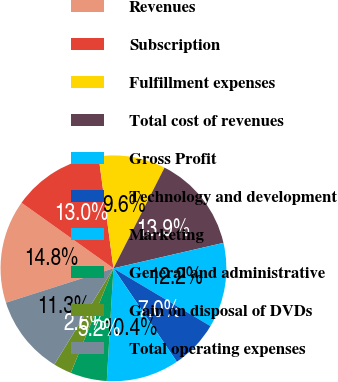<chart> <loc_0><loc_0><loc_500><loc_500><pie_chart><fcel>Revenues<fcel>Subscription<fcel>Fulfillment expenses<fcel>Total cost of revenues<fcel>Gross Profit<fcel>Technology and development<fcel>Marketing<fcel>General and administrative<fcel>Gain on disposal of DVDs<fcel>Total operating expenses<nl><fcel>14.78%<fcel>13.04%<fcel>9.57%<fcel>13.91%<fcel>12.17%<fcel>6.96%<fcel>10.43%<fcel>5.22%<fcel>2.61%<fcel>11.3%<nl></chart> 